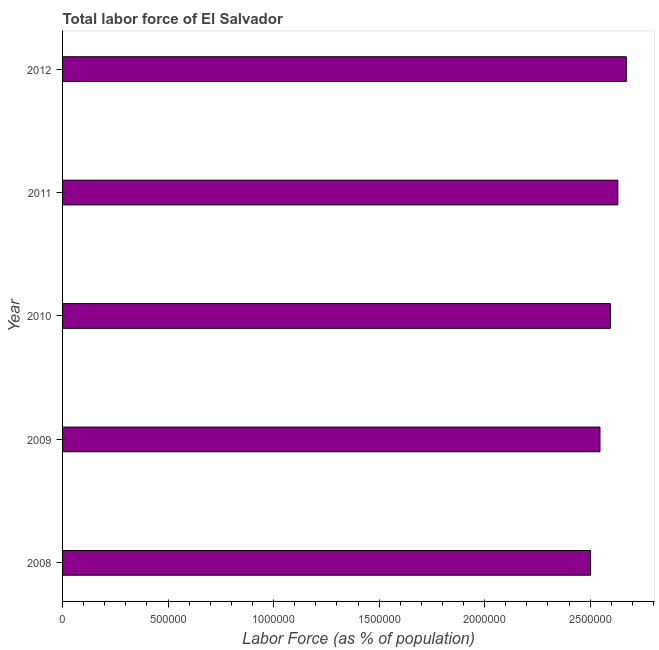Does the graph contain any zero values?
Make the answer very short. No. What is the title of the graph?
Your answer should be very brief. Total labor force of El Salvador. What is the label or title of the X-axis?
Your answer should be compact. Labor Force (as % of population). What is the total labor force in 2012?
Ensure brevity in your answer.  2.67e+06. Across all years, what is the maximum total labor force?
Offer a terse response. 2.67e+06. Across all years, what is the minimum total labor force?
Provide a short and direct response. 2.50e+06. In which year was the total labor force maximum?
Give a very brief answer. 2012. In which year was the total labor force minimum?
Ensure brevity in your answer.  2008. What is the sum of the total labor force?
Make the answer very short. 1.29e+07. What is the difference between the total labor force in 2009 and 2011?
Keep it short and to the point. -8.45e+04. What is the average total labor force per year?
Your answer should be very brief. 2.59e+06. What is the median total labor force?
Ensure brevity in your answer.  2.60e+06. Do a majority of the years between 2010 and 2012 (inclusive) have total labor force greater than 1500000 %?
Your answer should be compact. Yes. Is the total labor force in 2008 less than that in 2012?
Your answer should be compact. Yes. Is the difference between the total labor force in 2010 and 2012 greater than the difference between any two years?
Keep it short and to the point. No. What is the difference between the highest and the second highest total labor force?
Provide a short and direct response. 4.02e+04. What is the difference between the highest and the lowest total labor force?
Make the answer very short. 1.69e+05. In how many years, is the total labor force greater than the average total labor force taken over all years?
Offer a very short reply. 3. How many bars are there?
Your answer should be very brief. 5. How many years are there in the graph?
Make the answer very short. 5. What is the difference between two consecutive major ticks on the X-axis?
Your answer should be very brief. 5.00e+05. Are the values on the major ticks of X-axis written in scientific E-notation?
Ensure brevity in your answer.  No. What is the Labor Force (as % of population) of 2008?
Offer a very short reply. 2.50e+06. What is the Labor Force (as % of population) of 2009?
Your response must be concise. 2.55e+06. What is the Labor Force (as % of population) in 2010?
Make the answer very short. 2.60e+06. What is the Labor Force (as % of population) of 2011?
Offer a terse response. 2.63e+06. What is the Labor Force (as % of population) of 2012?
Your answer should be compact. 2.67e+06. What is the difference between the Labor Force (as % of population) in 2008 and 2009?
Your answer should be very brief. -4.45e+04. What is the difference between the Labor Force (as % of population) in 2008 and 2010?
Offer a very short reply. -9.42e+04. What is the difference between the Labor Force (as % of population) in 2008 and 2011?
Make the answer very short. -1.29e+05. What is the difference between the Labor Force (as % of population) in 2008 and 2012?
Provide a succinct answer. -1.69e+05. What is the difference between the Labor Force (as % of population) in 2009 and 2010?
Ensure brevity in your answer.  -4.97e+04. What is the difference between the Labor Force (as % of population) in 2009 and 2011?
Your answer should be compact. -8.45e+04. What is the difference between the Labor Force (as % of population) in 2009 and 2012?
Keep it short and to the point. -1.25e+05. What is the difference between the Labor Force (as % of population) in 2010 and 2011?
Your response must be concise. -3.47e+04. What is the difference between the Labor Force (as % of population) in 2010 and 2012?
Your response must be concise. -7.50e+04. What is the difference between the Labor Force (as % of population) in 2011 and 2012?
Make the answer very short. -4.02e+04. What is the ratio of the Labor Force (as % of population) in 2008 to that in 2009?
Keep it short and to the point. 0.98. What is the ratio of the Labor Force (as % of population) in 2008 to that in 2010?
Offer a terse response. 0.96. What is the ratio of the Labor Force (as % of population) in 2008 to that in 2011?
Ensure brevity in your answer.  0.95. What is the ratio of the Labor Force (as % of population) in 2008 to that in 2012?
Provide a short and direct response. 0.94. What is the ratio of the Labor Force (as % of population) in 2009 to that in 2010?
Offer a very short reply. 0.98. What is the ratio of the Labor Force (as % of population) in 2009 to that in 2011?
Give a very brief answer. 0.97. What is the ratio of the Labor Force (as % of population) in 2009 to that in 2012?
Offer a very short reply. 0.95. What is the ratio of the Labor Force (as % of population) in 2010 to that in 2012?
Your answer should be compact. 0.97. 